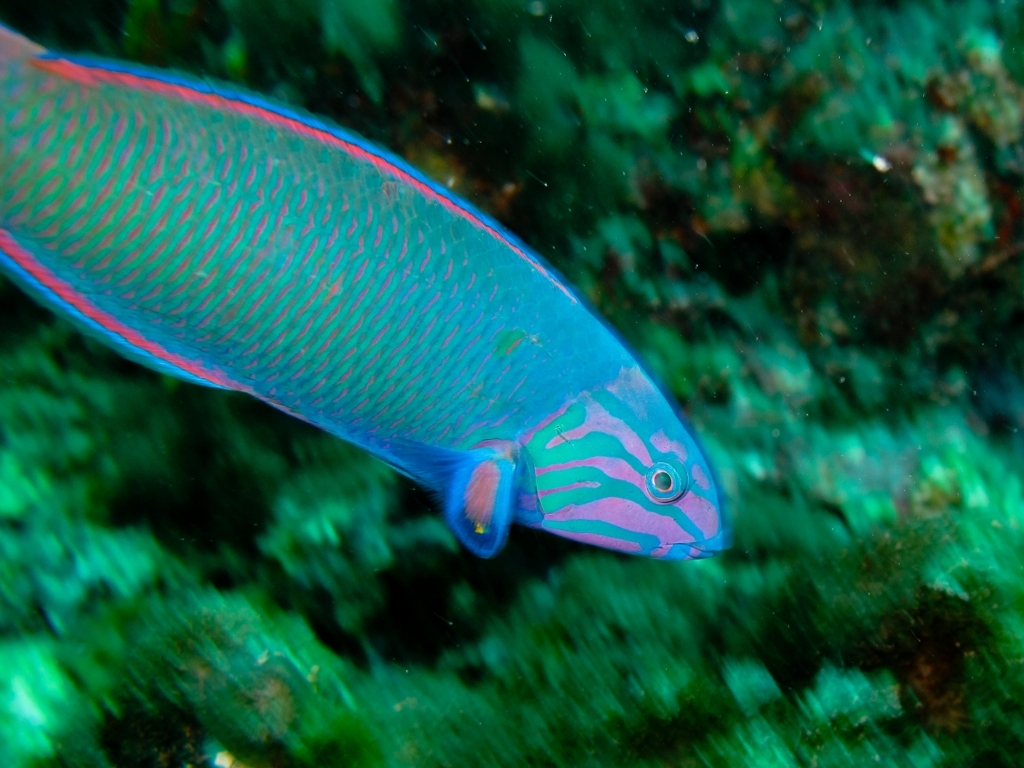What species of fish is this and what can you tell me about it? This appears to be a Parrotfish, recognizable by its bright colors and beak-like mouth. Parrotfish play a crucial role in maintaining the health of coral reefs by grazing on algae. 